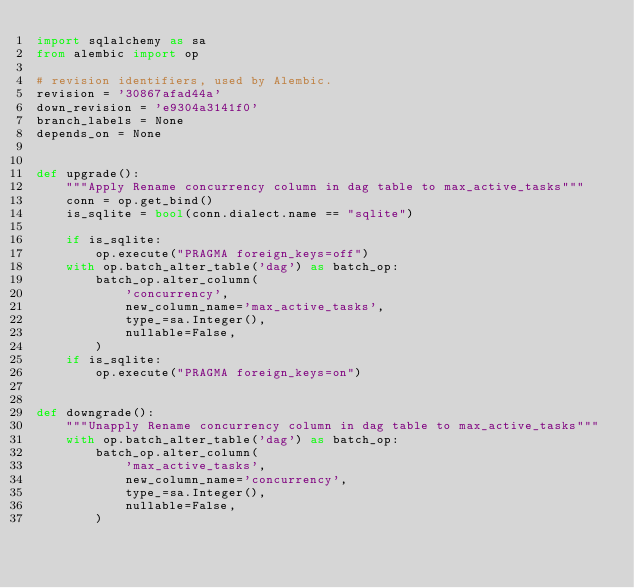<code> <loc_0><loc_0><loc_500><loc_500><_Python_>import sqlalchemy as sa
from alembic import op

# revision identifiers, used by Alembic.
revision = '30867afad44a'
down_revision = 'e9304a3141f0'
branch_labels = None
depends_on = None


def upgrade():
    """Apply Rename concurrency column in dag table to max_active_tasks"""
    conn = op.get_bind()
    is_sqlite = bool(conn.dialect.name == "sqlite")

    if is_sqlite:
        op.execute("PRAGMA foreign_keys=off")
    with op.batch_alter_table('dag') as batch_op:
        batch_op.alter_column(
            'concurrency',
            new_column_name='max_active_tasks',
            type_=sa.Integer(),
            nullable=False,
        )
    if is_sqlite:
        op.execute("PRAGMA foreign_keys=on")


def downgrade():
    """Unapply Rename concurrency column in dag table to max_active_tasks"""
    with op.batch_alter_table('dag') as batch_op:
        batch_op.alter_column(
            'max_active_tasks',
            new_column_name='concurrency',
            type_=sa.Integer(),
            nullable=False,
        )
</code> 